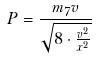<formula> <loc_0><loc_0><loc_500><loc_500>P = \frac { m _ { 7 } v } { \sqrt { 8 \cdot \frac { v ^ { 2 } } { x ^ { 2 } } } }</formula> 